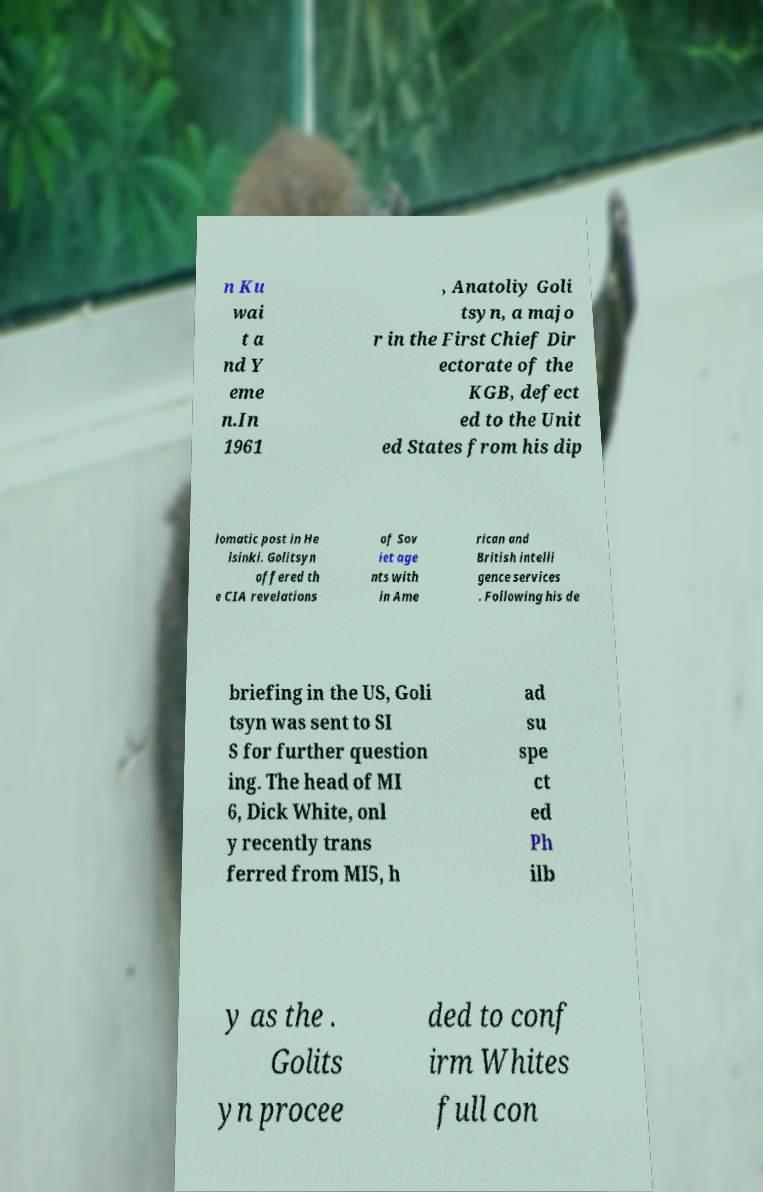Could you assist in decoding the text presented in this image and type it out clearly? n Ku wai t a nd Y eme n.In 1961 , Anatoliy Goli tsyn, a majo r in the First Chief Dir ectorate of the KGB, defect ed to the Unit ed States from his dip lomatic post in He lsinki. Golitsyn offered th e CIA revelations of Sov iet age nts with in Ame rican and British intelli gence services . Following his de briefing in the US, Goli tsyn was sent to SI S for further question ing. The head of MI 6, Dick White, onl y recently trans ferred from MI5, h ad su spe ct ed Ph ilb y as the . Golits yn procee ded to conf irm Whites full con 